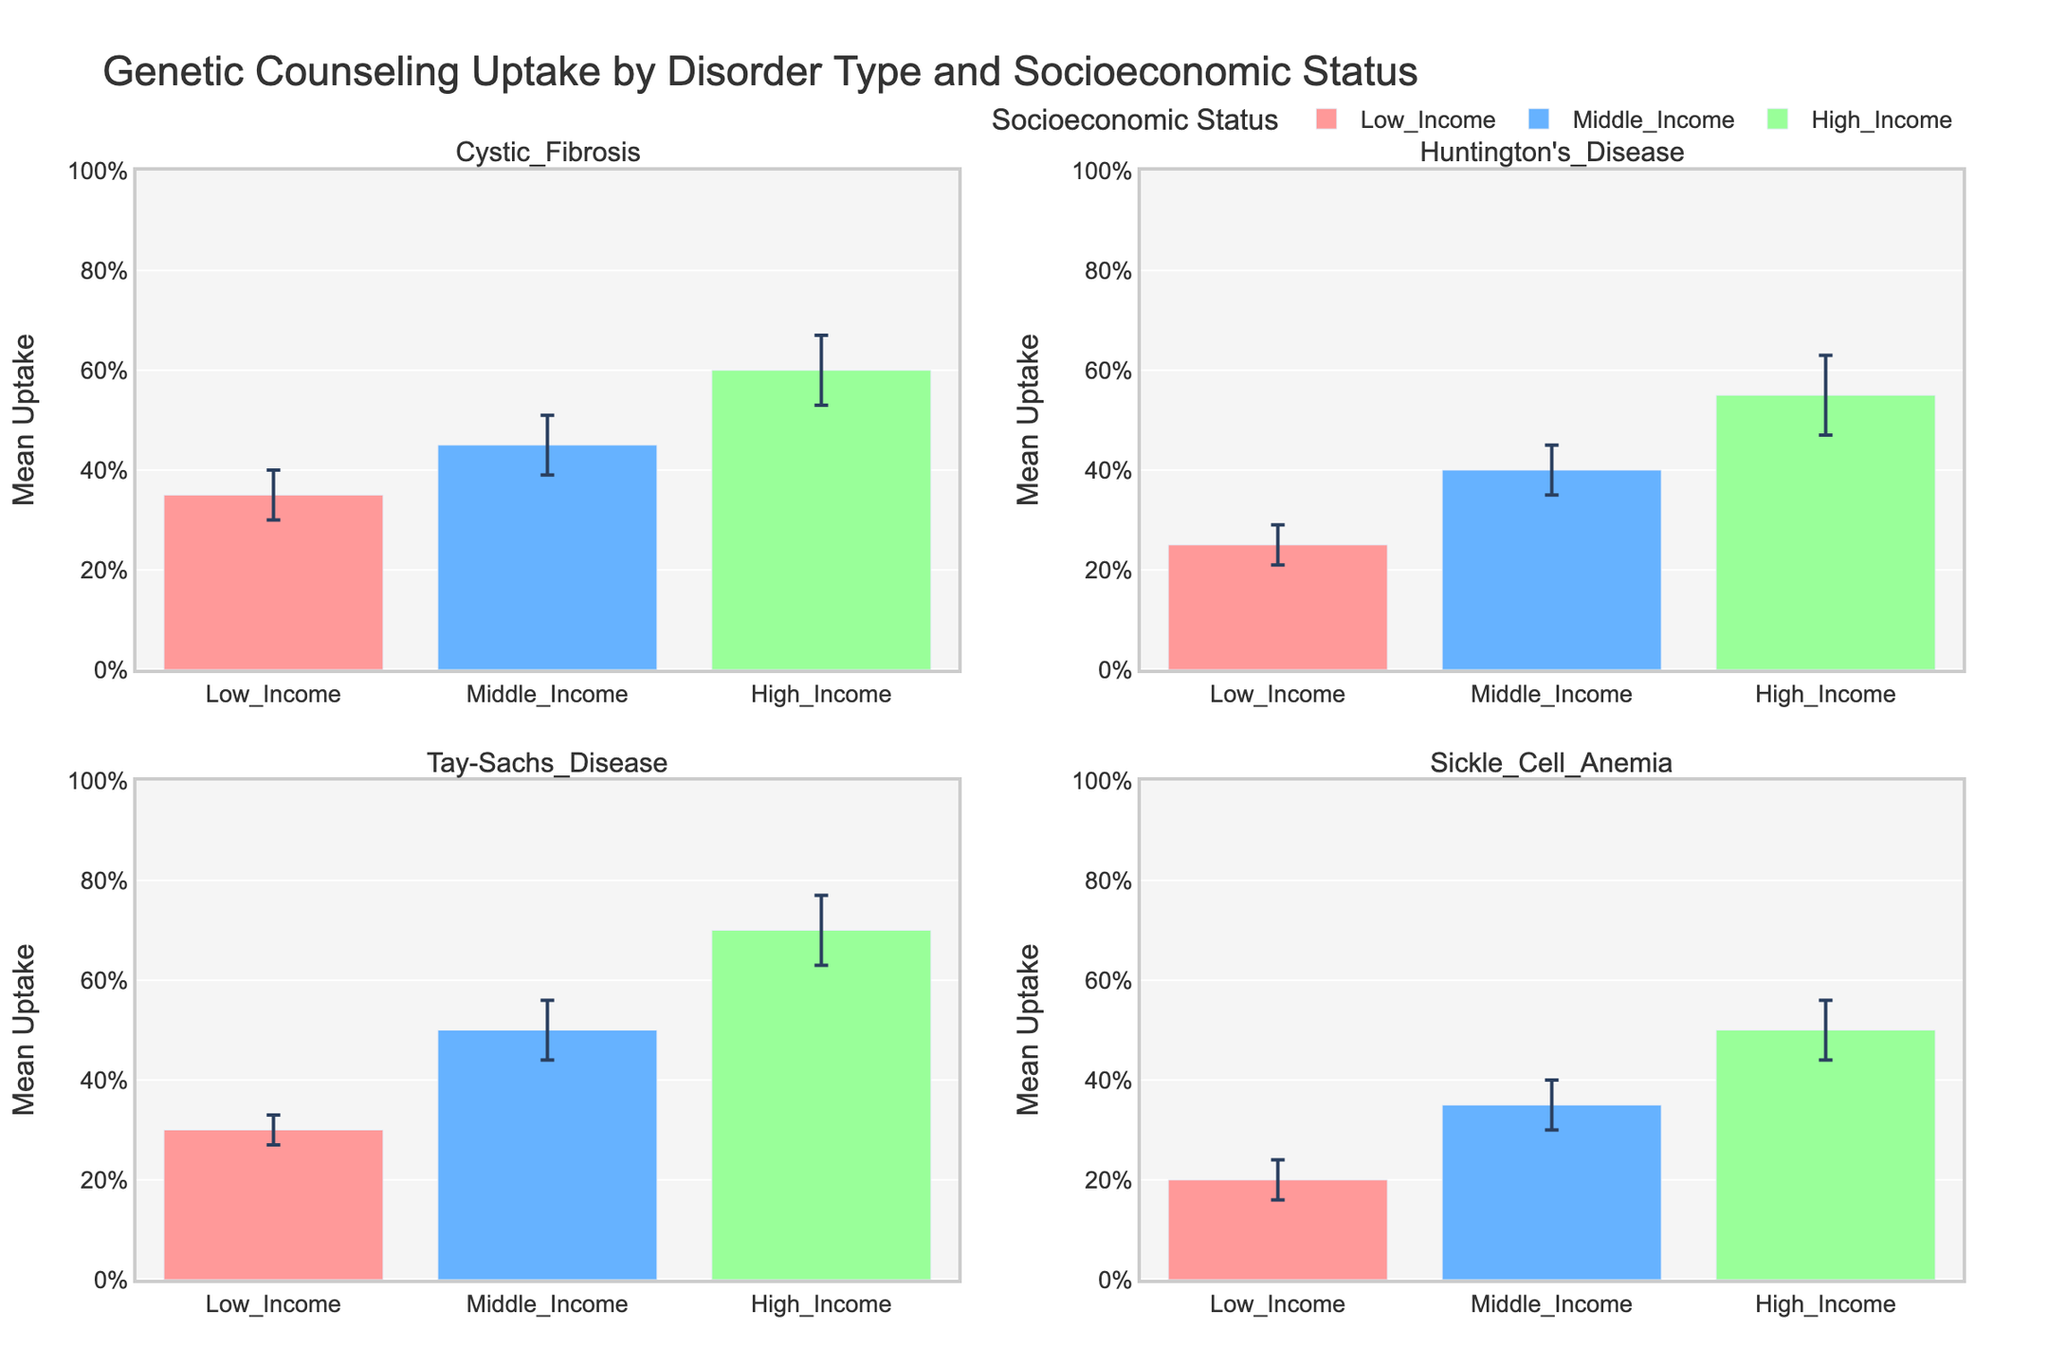What is the title of the figure? The title is prominently displayed at the top center of the figure.
Answer: Genetic Counseling Uptake by Disorder Type and Socioeconomic Status How many disorder types are represented in the subplots? The subplot titles indicate the different disorder types.
Answer: 4 Which socioeconomic status category has the highest mean uptake for Tay-Sachs Disease? Look at the subplot for Tay-Sachs Disease and compare the mean uptake bars for each socioeconomic status.
Answer: High Income What is the mean uptake for middle-income individuals with Cystic Fibrosis? Look at the bar corresponding to middle-income in the Cystic Fibrosis subplot.
Answer: 0.45 Which disorder has the lowest mean uptake for low-income individuals? Look at the bars for the low-income category across all subplots and identify the smallest value.
Answer: Sickle Cell Anemia Which disorder type shows the largest difference in mean uptake between high-income and low-income categories? Calculate the differences between the high-income and low-income mean uptake for each disorder type and find the largest one.
Answer: Tay-Sachs Disease What is the standard deviation for high-income individuals with Huntington's Disease? Look at the error bar for high-income in the Huntington's Disease subplot.
Answer: 0.08 Compare the mean uptake for middle-income individuals between Sickle Cell Anemia and Huntington's Disease. Which is higher? Compare the mean uptake bars for the middle-income category in both Sickle Cell Anemia and Huntington's Disease subplots.
Answer: Huntington's Disease For which disorder type does the middle-income category show the highest variability in uptake (standard deviation)? Compare the standard deviation lengths for the middle-income category across all disorder types.
Answer: Tay-Sachs Disease Arrange the mean uptake for high-income individuals in ascending order across all disorder types. Look at the high-income bars in each subplot and list the uptakes from lowest to highest.
Answer: Sickle Cell Anemia, Huntington's Disease, Cystic Fibrosis, Tay-Sachs Disease 